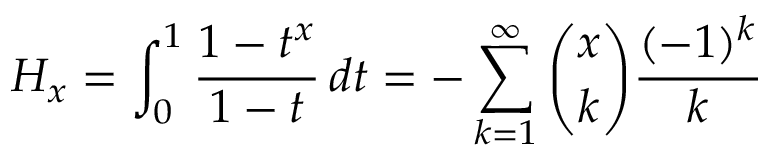<formula> <loc_0><loc_0><loc_500><loc_500>H _ { x } = \int _ { 0 } ^ { 1 } { \frac { 1 - t ^ { x } } { 1 - t } } \, d t = - \sum _ { k = 1 } ^ { \infty } { \binom { x } { k } } { \frac { ( - 1 ) ^ { k } } { k } }</formula> 